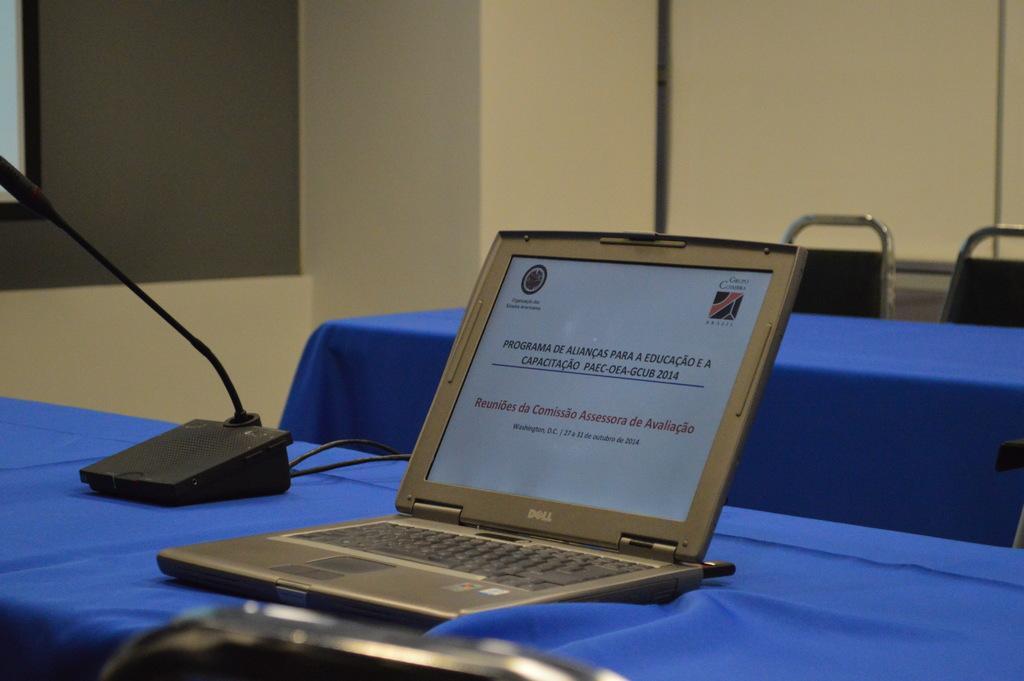In one or two sentences, can you explain what this image depicts? In this image we can see a laptop and a mike stand on the top of the table and the table is covered with blue color cloth. We can also see the empty table with two chairs. Image also consists of plain wall. On the left we can see the screen. 